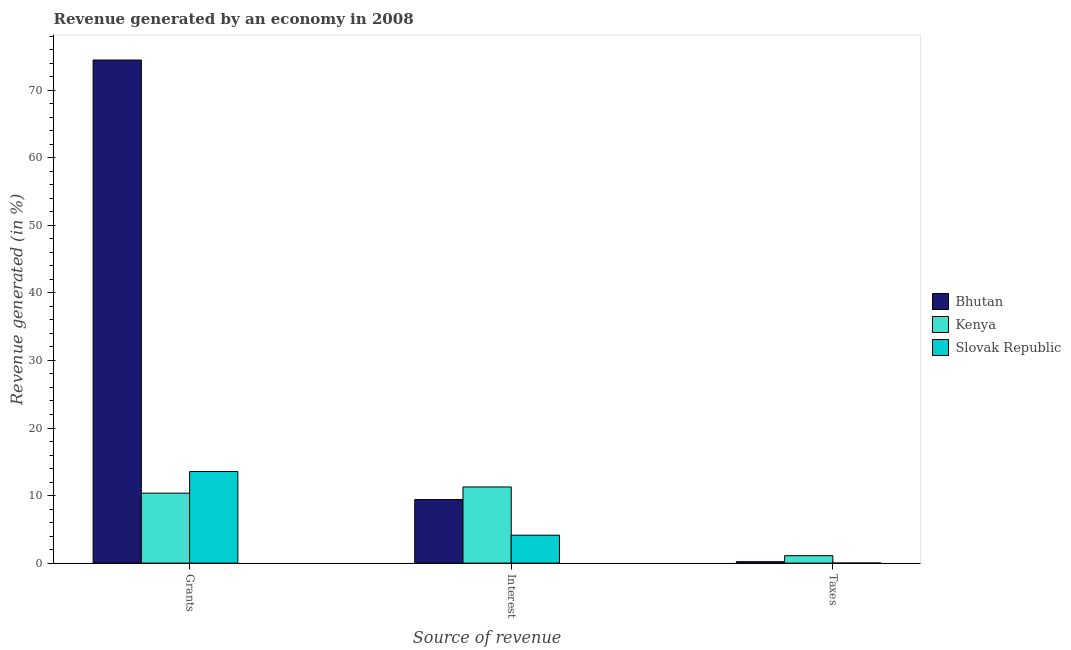Are the number of bars per tick equal to the number of legend labels?
Offer a very short reply. Yes. Are the number of bars on each tick of the X-axis equal?
Give a very brief answer. Yes. How many bars are there on the 1st tick from the left?
Keep it short and to the point. 3. What is the label of the 1st group of bars from the left?
Ensure brevity in your answer.  Grants. What is the percentage of revenue generated by taxes in Kenya?
Offer a terse response. 1.1. Across all countries, what is the maximum percentage of revenue generated by grants?
Offer a terse response. 74.48. Across all countries, what is the minimum percentage of revenue generated by interest?
Your answer should be compact. 4.13. In which country was the percentage of revenue generated by taxes maximum?
Provide a short and direct response. Kenya. In which country was the percentage of revenue generated by interest minimum?
Keep it short and to the point. Slovak Republic. What is the total percentage of revenue generated by grants in the graph?
Provide a short and direct response. 98.39. What is the difference between the percentage of revenue generated by interest in Slovak Republic and that in Bhutan?
Provide a succinct answer. -5.27. What is the difference between the percentage of revenue generated by interest in Bhutan and the percentage of revenue generated by taxes in Kenya?
Provide a succinct answer. 8.31. What is the average percentage of revenue generated by interest per country?
Give a very brief answer. 8.27. What is the difference between the percentage of revenue generated by interest and percentage of revenue generated by grants in Bhutan?
Give a very brief answer. -65.07. In how many countries, is the percentage of revenue generated by interest greater than 54 %?
Your response must be concise. 0. What is the ratio of the percentage of revenue generated by interest in Kenya to that in Slovak Republic?
Provide a succinct answer. 2.73. Is the percentage of revenue generated by grants in Kenya less than that in Slovak Republic?
Provide a short and direct response. Yes. What is the difference between the highest and the second highest percentage of revenue generated by grants?
Your response must be concise. 60.91. What is the difference between the highest and the lowest percentage of revenue generated by grants?
Your answer should be compact. 64.12. What does the 3rd bar from the left in Taxes represents?
Provide a succinct answer. Slovak Republic. What does the 3rd bar from the right in Interest represents?
Ensure brevity in your answer.  Bhutan. Are all the bars in the graph horizontal?
Your response must be concise. No. How many countries are there in the graph?
Your answer should be compact. 3. What is the difference between two consecutive major ticks on the Y-axis?
Keep it short and to the point. 10. Does the graph contain any zero values?
Give a very brief answer. No. How many legend labels are there?
Give a very brief answer. 3. What is the title of the graph?
Offer a very short reply. Revenue generated by an economy in 2008. Does "Maldives" appear as one of the legend labels in the graph?
Your response must be concise. No. What is the label or title of the X-axis?
Provide a short and direct response. Source of revenue. What is the label or title of the Y-axis?
Your answer should be compact. Revenue generated (in %). What is the Revenue generated (in %) in Bhutan in Grants?
Make the answer very short. 74.48. What is the Revenue generated (in %) in Kenya in Grants?
Keep it short and to the point. 10.36. What is the Revenue generated (in %) of Slovak Republic in Grants?
Ensure brevity in your answer.  13.56. What is the Revenue generated (in %) in Bhutan in Interest?
Your response must be concise. 9.41. What is the Revenue generated (in %) of Kenya in Interest?
Provide a short and direct response. 11.27. What is the Revenue generated (in %) in Slovak Republic in Interest?
Ensure brevity in your answer.  4.13. What is the Revenue generated (in %) of Bhutan in Taxes?
Ensure brevity in your answer.  0.21. What is the Revenue generated (in %) of Kenya in Taxes?
Your answer should be very brief. 1.1. What is the Revenue generated (in %) in Slovak Republic in Taxes?
Provide a succinct answer. 0.01. Across all Source of revenue, what is the maximum Revenue generated (in %) in Bhutan?
Offer a terse response. 74.48. Across all Source of revenue, what is the maximum Revenue generated (in %) in Kenya?
Make the answer very short. 11.27. Across all Source of revenue, what is the maximum Revenue generated (in %) of Slovak Republic?
Offer a terse response. 13.56. Across all Source of revenue, what is the minimum Revenue generated (in %) in Bhutan?
Keep it short and to the point. 0.21. Across all Source of revenue, what is the minimum Revenue generated (in %) in Kenya?
Give a very brief answer. 1.1. Across all Source of revenue, what is the minimum Revenue generated (in %) of Slovak Republic?
Make the answer very short. 0.01. What is the total Revenue generated (in %) of Bhutan in the graph?
Ensure brevity in your answer.  84.09. What is the total Revenue generated (in %) of Kenya in the graph?
Ensure brevity in your answer.  22.73. What is the total Revenue generated (in %) in Slovak Republic in the graph?
Make the answer very short. 17.7. What is the difference between the Revenue generated (in %) of Bhutan in Grants and that in Interest?
Your answer should be compact. 65.07. What is the difference between the Revenue generated (in %) of Kenya in Grants and that in Interest?
Give a very brief answer. -0.92. What is the difference between the Revenue generated (in %) of Slovak Republic in Grants and that in Interest?
Offer a terse response. 9.43. What is the difference between the Revenue generated (in %) of Bhutan in Grants and that in Taxes?
Provide a short and direct response. 74.26. What is the difference between the Revenue generated (in %) in Kenya in Grants and that in Taxes?
Your answer should be compact. 9.26. What is the difference between the Revenue generated (in %) in Slovak Republic in Grants and that in Taxes?
Make the answer very short. 13.55. What is the difference between the Revenue generated (in %) in Bhutan in Interest and that in Taxes?
Provide a succinct answer. 9.19. What is the difference between the Revenue generated (in %) of Kenya in Interest and that in Taxes?
Offer a terse response. 10.17. What is the difference between the Revenue generated (in %) of Slovak Republic in Interest and that in Taxes?
Offer a very short reply. 4.13. What is the difference between the Revenue generated (in %) of Bhutan in Grants and the Revenue generated (in %) of Kenya in Interest?
Offer a terse response. 63.2. What is the difference between the Revenue generated (in %) of Bhutan in Grants and the Revenue generated (in %) of Slovak Republic in Interest?
Make the answer very short. 70.34. What is the difference between the Revenue generated (in %) of Kenya in Grants and the Revenue generated (in %) of Slovak Republic in Interest?
Make the answer very short. 6.22. What is the difference between the Revenue generated (in %) in Bhutan in Grants and the Revenue generated (in %) in Kenya in Taxes?
Offer a very short reply. 73.37. What is the difference between the Revenue generated (in %) of Bhutan in Grants and the Revenue generated (in %) of Slovak Republic in Taxes?
Ensure brevity in your answer.  74.47. What is the difference between the Revenue generated (in %) in Kenya in Grants and the Revenue generated (in %) in Slovak Republic in Taxes?
Your answer should be compact. 10.35. What is the difference between the Revenue generated (in %) in Bhutan in Interest and the Revenue generated (in %) in Kenya in Taxes?
Offer a very short reply. 8.3. What is the difference between the Revenue generated (in %) of Bhutan in Interest and the Revenue generated (in %) of Slovak Republic in Taxes?
Your answer should be very brief. 9.4. What is the difference between the Revenue generated (in %) in Kenya in Interest and the Revenue generated (in %) in Slovak Republic in Taxes?
Your response must be concise. 11.27. What is the average Revenue generated (in %) in Bhutan per Source of revenue?
Provide a short and direct response. 28.03. What is the average Revenue generated (in %) in Kenya per Source of revenue?
Keep it short and to the point. 7.58. What is the average Revenue generated (in %) in Slovak Republic per Source of revenue?
Offer a very short reply. 5.9. What is the difference between the Revenue generated (in %) in Bhutan and Revenue generated (in %) in Kenya in Grants?
Your answer should be very brief. 64.12. What is the difference between the Revenue generated (in %) in Bhutan and Revenue generated (in %) in Slovak Republic in Grants?
Give a very brief answer. 60.91. What is the difference between the Revenue generated (in %) of Kenya and Revenue generated (in %) of Slovak Republic in Grants?
Your answer should be compact. -3.2. What is the difference between the Revenue generated (in %) in Bhutan and Revenue generated (in %) in Kenya in Interest?
Make the answer very short. -1.87. What is the difference between the Revenue generated (in %) in Bhutan and Revenue generated (in %) in Slovak Republic in Interest?
Keep it short and to the point. 5.27. What is the difference between the Revenue generated (in %) of Kenya and Revenue generated (in %) of Slovak Republic in Interest?
Keep it short and to the point. 7.14. What is the difference between the Revenue generated (in %) of Bhutan and Revenue generated (in %) of Kenya in Taxes?
Give a very brief answer. -0.89. What is the difference between the Revenue generated (in %) of Bhutan and Revenue generated (in %) of Slovak Republic in Taxes?
Provide a short and direct response. 0.2. What is the difference between the Revenue generated (in %) in Kenya and Revenue generated (in %) in Slovak Republic in Taxes?
Provide a succinct answer. 1.09. What is the ratio of the Revenue generated (in %) in Bhutan in Grants to that in Interest?
Offer a very short reply. 7.92. What is the ratio of the Revenue generated (in %) of Kenya in Grants to that in Interest?
Your response must be concise. 0.92. What is the ratio of the Revenue generated (in %) of Slovak Republic in Grants to that in Interest?
Provide a short and direct response. 3.28. What is the ratio of the Revenue generated (in %) in Bhutan in Grants to that in Taxes?
Ensure brevity in your answer.  352.17. What is the ratio of the Revenue generated (in %) in Kenya in Grants to that in Taxes?
Provide a succinct answer. 9.41. What is the ratio of the Revenue generated (in %) of Slovak Republic in Grants to that in Taxes?
Keep it short and to the point. 1928.19. What is the ratio of the Revenue generated (in %) of Bhutan in Interest to that in Taxes?
Your answer should be compact. 44.48. What is the ratio of the Revenue generated (in %) of Kenya in Interest to that in Taxes?
Provide a succinct answer. 10.24. What is the ratio of the Revenue generated (in %) of Slovak Republic in Interest to that in Taxes?
Your answer should be very brief. 587.79. What is the difference between the highest and the second highest Revenue generated (in %) in Bhutan?
Your response must be concise. 65.07. What is the difference between the highest and the second highest Revenue generated (in %) of Kenya?
Offer a terse response. 0.92. What is the difference between the highest and the second highest Revenue generated (in %) of Slovak Republic?
Give a very brief answer. 9.43. What is the difference between the highest and the lowest Revenue generated (in %) in Bhutan?
Ensure brevity in your answer.  74.26. What is the difference between the highest and the lowest Revenue generated (in %) in Kenya?
Your answer should be very brief. 10.17. What is the difference between the highest and the lowest Revenue generated (in %) of Slovak Republic?
Your answer should be very brief. 13.55. 